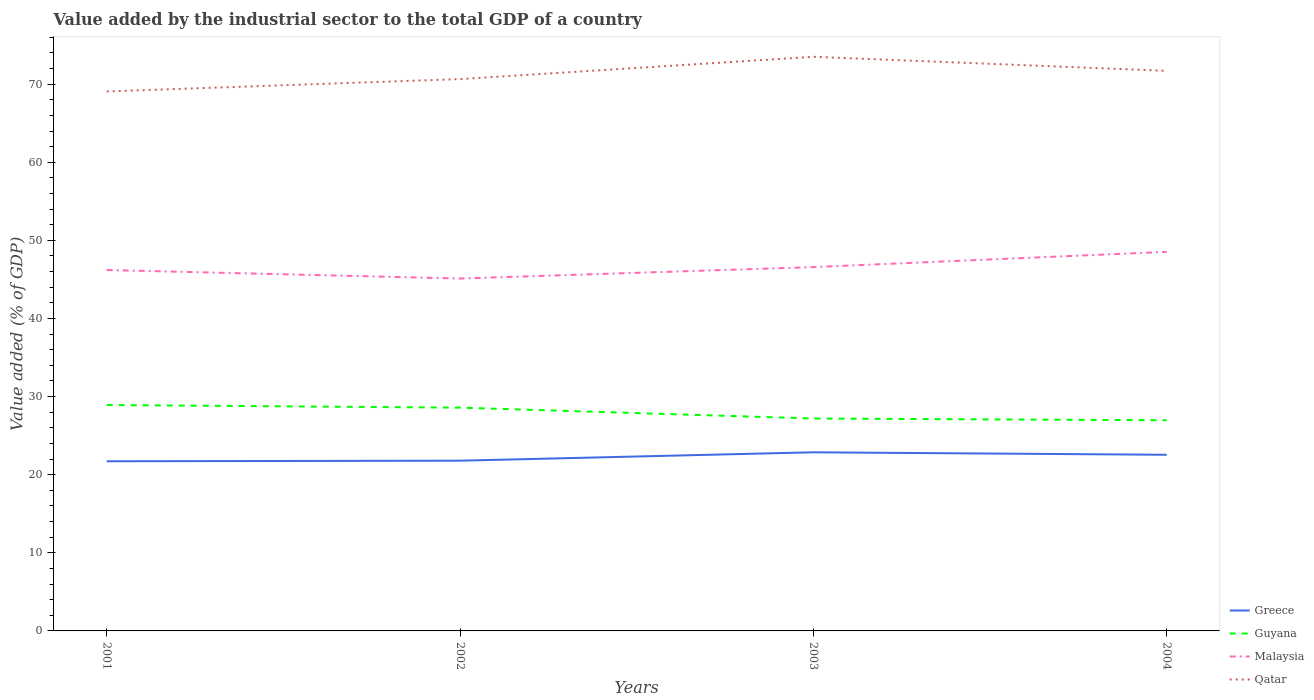Does the line corresponding to Greece intersect with the line corresponding to Malaysia?
Give a very brief answer. No. Across all years, what is the maximum value added by the industrial sector to the total GDP in Guyana?
Provide a short and direct response. 26.97. What is the total value added by the industrial sector to the total GDP in Greece in the graph?
Your answer should be compact. -0.83. What is the difference between the highest and the second highest value added by the industrial sector to the total GDP in Guyana?
Your answer should be compact. 1.95. What is the difference between the highest and the lowest value added by the industrial sector to the total GDP in Guyana?
Your answer should be compact. 2. Is the value added by the industrial sector to the total GDP in Malaysia strictly greater than the value added by the industrial sector to the total GDP in Greece over the years?
Give a very brief answer. No. How many years are there in the graph?
Your answer should be very brief. 4. Are the values on the major ticks of Y-axis written in scientific E-notation?
Provide a succinct answer. No. What is the title of the graph?
Ensure brevity in your answer.  Value added by the industrial sector to the total GDP of a country. Does "Euro area" appear as one of the legend labels in the graph?
Provide a succinct answer. No. What is the label or title of the Y-axis?
Ensure brevity in your answer.  Value added (% of GDP). What is the Value added (% of GDP) in Greece in 2001?
Provide a short and direct response. 21.72. What is the Value added (% of GDP) of Guyana in 2001?
Give a very brief answer. 28.92. What is the Value added (% of GDP) of Malaysia in 2001?
Provide a short and direct response. 46.2. What is the Value added (% of GDP) in Qatar in 2001?
Ensure brevity in your answer.  69.07. What is the Value added (% of GDP) in Greece in 2002?
Offer a very short reply. 21.79. What is the Value added (% of GDP) in Guyana in 2002?
Offer a terse response. 28.58. What is the Value added (% of GDP) in Malaysia in 2002?
Make the answer very short. 45.12. What is the Value added (% of GDP) of Qatar in 2002?
Offer a terse response. 70.65. What is the Value added (% of GDP) in Greece in 2003?
Offer a terse response. 22.87. What is the Value added (% of GDP) of Guyana in 2003?
Keep it short and to the point. 27.19. What is the Value added (% of GDP) of Malaysia in 2003?
Ensure brevity in your answer.  46.58. What is the Value added (% of GDP) of Qatar in 2003?
Your response must be concise. 73.5. What is the Value added (% of GDP) of Greece in 2004?
Provide a short and direct response. 22.55. What is the Value added (% of GDP) of Guyana in 2004?
Your answer should be compact. 26.97. What is the Value added (% of GDP) in Malaysia in 2004?
Give a very brief answer. 48.53. What is the Value added (% of GDP) in Qatar in 2004?
Your answer should be very brief. 71.7. Across all years, what is the maximum Value added (% of GDP) in Greece?
Make the answer very short. 22.87. Across all years, what is the maximum Value added (% of GDP) in Guyana?
Your answer should be very brief. 28.92. Across all years, what is the maximum Value added (% of GDP) in Malaysia?
Your answer should be very brief. 48.53. Across all years, what is the maximum Value added (% of GDP) of Qatar?
Keep it short and to the point. 73.5. Across all years, what is the minimum Value added (% of GDP) in Greece?
Provide a succinct answer. 21.72. Across all years, what is the minimum Value added (% of GDP) of Guyana?
Provide a short and direct response. 26.97. Across all years, what is the minimum Value added (% of GDP) of Malaysia?
Make the answer very short. 45.12. Across all years, what is the minimum Value added (% of GDP) in Qatar?
Your response must be concise. 69.07. What is the total Value added (% of GDP) of Greece in the graph?
Make the answer very short. 88.93. What is the total Value added (% of GDP) of Guyana in the graph?
Your answer should be very brief. 111.67. What is the total Value added (% of GDP) in Malaysia in the graph?
Provide a succinct answer. 186.43. What is the total Value added (% of GDP) in Qatar in the graph?
Your answer should be compact. 284.92. What is the difference between the Value added (% of GDP) in Greece in 2001 and that in 2002?
Make the answer very short. -0.07. What is the difference between the Value added (% of GDP) in Guyana in 2001 and that in 2002?
Provide a short and direct response. 0.34. What is the difference between the Value added (% of GDP) of Malaysia in 2001 and that in 2002?
Offer a terse response. 1.09. What is the difference between the Value added (% of GDP) in Qatar in 2001 and that in 2002?
Provide a succinct answer. -1.58. What is the difference between the Value added (% of GDP) of Greece in 2001 and that in 2003?
Provide a short and direct response. -1.15. What is the difference between the Value added (% of GDP) of Guyana in 2001 and that in 2003?
Make the answer very short. 1.73. What is the difference between the Value added (% of GDP) in Malaysia in 2001 and that in 2003?
Your answer should be compact. -0.37. What is the difference between the Value added (% of GDP) of Qatar in 2001 and that in 2003?
Provide a short and direct response. -4.43. What is the difference between the Value added (% of GDP) of Greece in 2001 and that in 2004?
Offer a very short reply. -0.83. What is the difference between the Value added (% of GDP) in Guyana in 2001 and that in 2004?
Provide a short and direct response. 1.95. What is the difference between the Value added (% of GDP) of Malaysia in 2001 and that in 2004?
Provide a succinct answer. -2.33. What is the difference between the Value added (% of GDP) in Qatar in 2001 and that in 2004?
Your answer should be very brief. -2.64. What is the difference between the Value added (% of GDP) of Greece in 2002 and that in 2003?
Ensure brevity in your answer.  -1.07. What is the difference between the Value added (% of GDP) in Guyana in 2002 and that in 2003?
Your response must be concise. 1.39. What is the difference between the Value added (% of GDP) in Malaysia in 2002 and that in 2003?
Ensure brevity in your answer.  -1.46. What is the difference between the Value added (% of GDP) in Qatar in 2002 and that in 2003?
Keep it short and to the point. -2.85. What is the difference between the Value added (% of GDP) of Greece in 2002 and that in 2004?
Ensure brevity in your answer.  -0.76. What is the difference between the Value added (% of GDP) in Guyana in 2002 and that in 2004?
Provide a succinct answer. 1.61. What is the difference between the Value added (% of GDP) of Malaysia in 2002 and that in 2004?
Make the answer very short. -3.41. What is the difference between the Value added (% of GDP) in Qatar in 2002 and that in 2004?
Your answer should be very brief. -1.06. What is the difference between the Value added (% of GDP) of Greece in 2003 and that in 2004?
Offer a terse response. 0.32. What is the difference between the Value added (% of GDP) of Guyana in 2003 and that in 2004?
Ensure brevity in your answer.  0.22. What is the difference between the Value added (% of GDP) in Malaysia in 2003 and that in 2004?
Keep it short and to the point. -1.95. What is the difference between the Value added (% of GDP) in Qatar in 2003 and that in 2004?
Offer a very short reply. 1.8. What is the difference between the Value added (% of GDP) of Greece in 2001 and the Value added (% of GDP) of Guyana in 2002?
Keep it short and to the point. -6.86. What is the difference between the Value added (% of GDP) in Greece in 2001 and the Value added (% of GDP) in Malaysia in 2002?
Keep it short and to the point. -23.4. What is the difference between the Value added (% of GDP) in Greece in 2001 and the Value added (% of GDP) in Qatar in 2002?
Provide a succinct answer. -48.93. What is the difference between the Value added (% of GDP) of Guyana in 2001 and the Value added (% of GDP) of Malaysia in 2002?
Offer a very short reply. -16.19. What is the difference between the Value added (% of GDP) of Guyana in 2001 and the Value added (% of GDP) of Qatar in 2002?
Offer a very short reply. -41.73. What is the difference between the Value added (% of GDP) in Malaysia in 2001 and the Value added (% of GDP) in Qatar in 2002?
Your answer should be compact. -24.44. What is the difference between the Value added (% of GDP) of Greece in 2001 and the Value added (% of GDP) of Guyana in 2003?
Your answer should be compact. -5.47. What is the difference between the Value added (% of GDP) in Greece in 2001 and the Value added (% of GDP) in Malaysia in 2003?
Make the answer very short. -24.86. What is the difference between the Value added (% of GDP) in Greece in 2001 and the Value added (% of GDP) in Qatar in 2003?
Make the answer very short. -51.78. What is the difference between the Value added (% of GDP) in Guyana in 2001 and the Value added (% of GDP) in Malaysia in 2003?
Offer a very short reply. -17.66. What is the difference between the Value added (% of GDP) of Guyana in 2001 and the Value added (% of GDP) of Qatar in 2003?
Make the answer very short. -44.58. What is the difference between the Value added (% of GDP) of Malaysia in 2001 and the Value added (% of GDP) of Qatar in 2003?
Offer a very short reply. -27.3. What is the difference between the Value added (% of GDP) in Greece in 2001 and the Value added (% of GDP) in Guyana in 2004?
Your answer should be compact. -5.25. What is the difference between the Value added (% of GDP) of Greece in 2001 and the Value added (% of GDP) of Malaysia in 2004?
Your response must be concise. -26.81. What is the difference between the Value added (% of GDP) in Greece in 2001 and the Value added (% of GDP) in Qatar in 2004?
Your answer should be very brief. -49.98. What is the difference between the Value added (% of GDP) in Guyana in 2001 and the Value added (% of GDP) in Malaysia in 2004?
Keep it short and to the point. -19.61. What is the difference between the Value added (% of GDP) of Guyana in 2001 and the Value added (% of GDP) of Qatar in 2004?
Your answer should be very brief. -42.78. What is the difference between the Value added (% of GDP) in Malaysia in 2001 and the Value added (% of GDP) in Qatar in 2004?
Offer a terse response. -25.5. What is the difference between the Value added (% of GDP) of Greece in 2002 and the Value added (% of GDP) of Guyana in 2003?
Make the answer very short. -5.4. What is the difference between the Value added (% of GDP) of Greece in 2002 and the Value added (% of GDP) of Malaysia in 2003?
Provide a succinct answer. -24.78. What is the difference between the Value added (% of GDP) of Greece in 2002 and the Value added (% of GDP) of Qatar in 2003?
Provide a short and direct response. -51.71. What is the difference between the Value added (% of GDP) of Guyana in 2002 and the Value added (% of GDP) of Malaysia in 2003?
Offer a terse response. -17.99. What is the difference between the Value added (% of GDP) in Guyana in 2002 and the Value added (% of GDP) in Qatar in 2003?
Make the answer very short. -44.92. What is the difference between the Value added (% of GDP) of Malaysia in 2002 and the Value added (% of GDP) of Qatar in 2003?
Offer a terse response. -28.39. What is the difference between the Value added (% of GDP) in Greece in 2002 and the Value added (% of GDP) in Guyana in 2004?
Keep it short and to the point. -5.18. What is the difference between the Value added (% of GDP) in Greece in 2002 and the Value added (% of GDP) in Malaysia in 2004?
Keep it short and to the point. -26.74. What is the difference between the Value added (% of GDP) of Greece in 2002 and the Value added (% of GDP) of Qatar in 2004?
Your response must be concise. -49.91. What is the difference between the Value added (% of GDP) of Guyana in 2002 and the Value added (% of GDP) of Malaysia in 2004?
Keep it short and to the point. -19.95. What is the difference between the Value added (% of GDP) of Guyana in 2002 and the Value added (% of GDP) of Qatar in 2004?
Your answer should be compact. -43.12. What is the difference between the Value added (% of GDP) in Malaysia in 2002 and the Value added (% of GDP) in Qatar in 2004?
Make the answer very short. -26.59. What is the difference between the Value added (% of GDP) in Greece in 2003 and the Value added (% of GDP) in Guyana in 2004?
Give a very brief answer. -4.1. What is the difference between the Value added (% of GDP) in Greece in 2003 and the Value added (% of GDP) in Malaysia in 2004?
Keep it short and to the point. -25.66. What is the difference between the Value added (% of GDP) in Greece in 2003 and the Value added (% of GDP) in Qatar in 2004?
Give a very brief answer. -48.83. What is the difference between the Value added (% of GDP) in Guyana in 2003 and the Value added (% of GDP) in Malaysia in 2004?
Keep it short and to the point. -21.34. What is the difference between the Value added (% of GDP) of Guyana in 2003 and the Value added (% of GDP) of Qatar in 2004?
Ensure brevity in your answer.  -44.51. What is the difference between the Value added (% of GDP) in Malaysia in 2003 and the Value added (% of GDP) in Qatar in 2004?
Make the answer very short. -25.12. What is the average Value added (% of GDP) of Greece per year?
Offer a terse response. 22.23. What is the average Value added (% of GDP) in Guyana per year?
Give a very brief answer. 27.92. What is the average Value added (% of GDP) in Malaysia per year?
Keep it short and to the point. 46.61. What is the average Value added (% of GDP) in Qatar per year?
Make the answer very short. 71.23. In the year 2001, what is the difference between the Value added (% of GDP) in Greece and Value added (% of GDP) in Guyana?
Ensure brevity in your answer.  -7.2. In the year 2001, what is the difference between the Value added (% of GDP) in Greece and Value added (% of GDP) in Malaysia?
Make the answer very short. -24.48. In the year 2001, what is the difference between the Value added (% of GDP) of Greece and Value added (% of GDP) of Qatar?
Your response must be concise. -47.35. In the year 2001, what is the difference between the Value added (% of GDP) of Guyana and Value added (% of GDP) of Malaysia?
Your response must be concise. -17.28. In the year 2001, what is the difference between the Value added (% of GDP) in Guyana and Value added (% of GDP) in Qatar?
Offer a terse response. -40.15. In the year 2001, what is the difference between the Value added (% of GDP) of Malaysia and Value added (% of GDP) of Qatar?
Your answer should be very brief. -22.86. In the year 2002, what is the difference between the Value added (% of GDP) in Greece and Value added (% of GDP) in Guyana?
Give a very brief answer. -6.79. In the year 2002, what is the difference between the Value added (% of GDP) in Greece and Value added (% of GDP) in Malaysia?
Offer a terse response. -23.32. In the year 2002, what is the difference between the Value added (% of GDP) in Greece and Value added (% of GDP) in Qatar?
Your answer should be compact. -48.85. In the year 2002, what is the difference between the Value added (% of GDP) in Guyana and Value added (% of GDP) in Malaysia?
Your answer should be compact. -16.53. In the year 2002, what is the difference between the Value added (% of GDP) in Guyana and Value added (% of GDP) in Qatar?
Your response must be concise. -42.06. In the year 2002, what is the difference between the Value added (% of GDP) of Malaysia and Value added (% of GDP) of Qatar?
Give a very brief answer. -25.53. In the year 2003, what is the difference between the Value added (% of GDP) in Greece and Value added (% of GDP) in Guyana?
Provide a succinct answer. -4.32. In the year 2003, what is the difference between the Value added (% of GDP) of Greece and Value added (% of GDP) of Malaysia?
Keep it short and to the point. -23.71. In the year 2003, what is the difference between the Value added (% of GDP) of Greece and Value added (% of GDP) of Qatar?
Your answer should be very brief. -50.63. In the year 2003, what is the difference between the Value added (% of GDP) in Guyana and Value added (% of GDP) in Malaysia?
Provide a succinct answer. -19.39. In the year 2003, what is the difference between the Value added (% of GDP) in Guyana and Value added (% of GDP) in Qatar?
Your response must be concise. -46.31. In the year 2003, what is the difference between the Value added (% of GDP) of Malaysia and Value added (% of GDP) of Qatar?
Your answer should be very brief. -26.92. In the year 2004, what is the difference between the Value added (% of GDP) in Greece and Value added (% of GDP) in Guyana?
Make the answer very short. -4.42. In the year 2004, what is the difference between the Value added (% of GDP) of Greece and Value added (% of GDP) of Malaysia?
Your response must be concise. -25.98. In the year 2004, what is the difference between the Value added (% of GDP) in Greece and Value added (% of GDP) in Qatar?
Keep it short and to the point. -49.15. In the year 2004, what is the difference between the Value added (% of GDP) in Guyana and Value added (% of GDP) in Malaysia?
Offer a very short reply. -21.56. In the year 2004, what is the difference between the Value added (% of GDP) in Guyana and Value added (% of GDP) in Qatar?
Your response must be concise. -44.73. In the year 2004, what is the difference between the Value added (% of GDP) of Malaysia and Value added (% of GDP) of Qatar?
Make the answer very short. -23.17. What is the ratio of the Value added (% of GDP) of Guyana in 2001 to that in 2002?
Ensure brevity in your answer.  1.01. What is the ratio of the Value added (% of GDP) of Malaysia in 2001 to that in 2002?
Make the answer very short. 1.02. What is the ratio of the Value added (% of GDP) of Qatar in 2001 to that in 2002?
Give a very brief answer. 0.98. What is the ratio of the Value added (% of GDP) in Greece in 2001 to that in 2003?
Provide a short and direct response. 0.95. What is the ratio of the Value added (% of GDP) in Guyana in 2001 to that in 2003?
Your answer should be compact. 1.06. What is the ratio of the Value added (% of GDP) in Malaysia in 2001 to that in 2003?
Provide a short and direct response. 0.99. What is the ratio of the Value added (% of GDP) of Qatar in 2001 to that in 2003?
Provide a succinct answer. 0.94. What is the ratio of the Value added (% of GDP) of Greece in 2001 to that in 2004?
Offer a terse response. 0.96. What is the ratio of the Value added (% of GDP) in Guyana in 2001 to that in 2004?
Give a very brief answer. 1.07. What is the ratio of the Value added (% of GDP) in Malaysia in 2001 to that in 2004?
Your response must be concise. 0.95. What is the ratio of the Value added (% of GDP) of Qatar in 2001 to that in 2004?
Your answer should be very brief. 0.96. What is the ratio of the Value added (% of GDP) in Greece in 2002 to that in 2003?
Your answer should be very brief. 0.95. What is the ratio of the Value added (% of GDP) in Guyana in 2002 to that in 2003?
Provide a short and direct response. 1.05. What is the ratio of the Value added (% of GDP) in Malaysia in 2002 to that in 2003?
Give a very brief answer. 0.97. What is the ratio of the Value added (% of GDP) of Qatar in 2002 to that in 2003?
Give a very brief answer. 0.96. What is the ratio of the Value added (% of GDP) of Greece in 2002 to that in 2004?
Your response must be concise. 0.97. What is the ratio of the Value added (% of GDP) in Guyana in 2002 to that in 2004?
Give a very brief answer. 1.06. What is the ratio of the Value added (% of GDP) of Malaysia in 2002 to that in 2004?
Keep it short and to the point. 0.93. What is the ratio of the Value added (% of GDP) in Qatar in 2002 to that in 2004?
Give a very brief answer. 0.99. What is the ratio of the Value added (% of GDP) in Greece in 2003 to that in 2004?
Offer a terse response. 1.01. What is the ratio of the Value added (% of GDP) in Guyana in 2003 to that in 2004?
Make the answer very short. 1.01. What is the ratio of the Value added (% of GDP) of Malaysia in 2003 to that in 2004?
Give a very brief answer. 0.96. What is the ratio of the Value added (% of GDP) in Qatar in 2003 to that in 2004?
Offer a terse response. 1.03. What is the difference between the highest and the second highest Value added (% of GDP) in Greece?
Give a very brief answer. 0.32. What is the difference between the highest and the second highest Value added (% of GDP) in Guyana?
Provide a succinct answer. 0.34. What is the difference between the highest and the second highest Value added (% of GDP) of Malaysia?
Your answer should be compact. 1.95. What is the difference between the highest and the second highest Value added (% of GDP) of Qatar?
Make the answer very short. 1.8. What is the difference between the highest and the lowest Value added (% of GDP) of Greece?
Offer a terse response. 1.15. What is the difference between the highest and the lowest Value added (% of GDP) of Guyana?
Your response must be concise. 1.95. What is the difference between the highest and the lowest Value added (% of GDP) of Malaysia?
Ensure brevity in your answer.  3.41. What is the difference between the highest and the lowest Value added (% of GDP) of Qatar?
Keep it short and to the point. 4.43. 